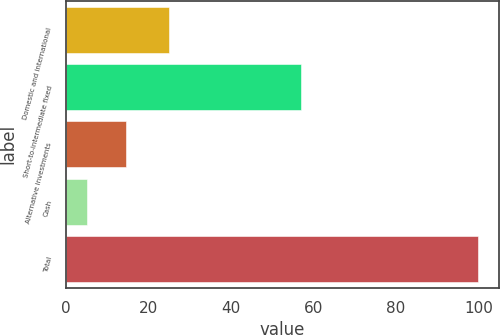Convert chart. <chart><loc_0><loc_0><loc_500><loc_500><bar_chart><fcel>Domestic and international<fcel>Short-to-intermediate fixed<fcel>Alternative investments<fcel>Cash<fcel>Total<nl><fcel>25<fcel>57<fcel>14.5<fcel>5<fcel>100<nl></chart> 